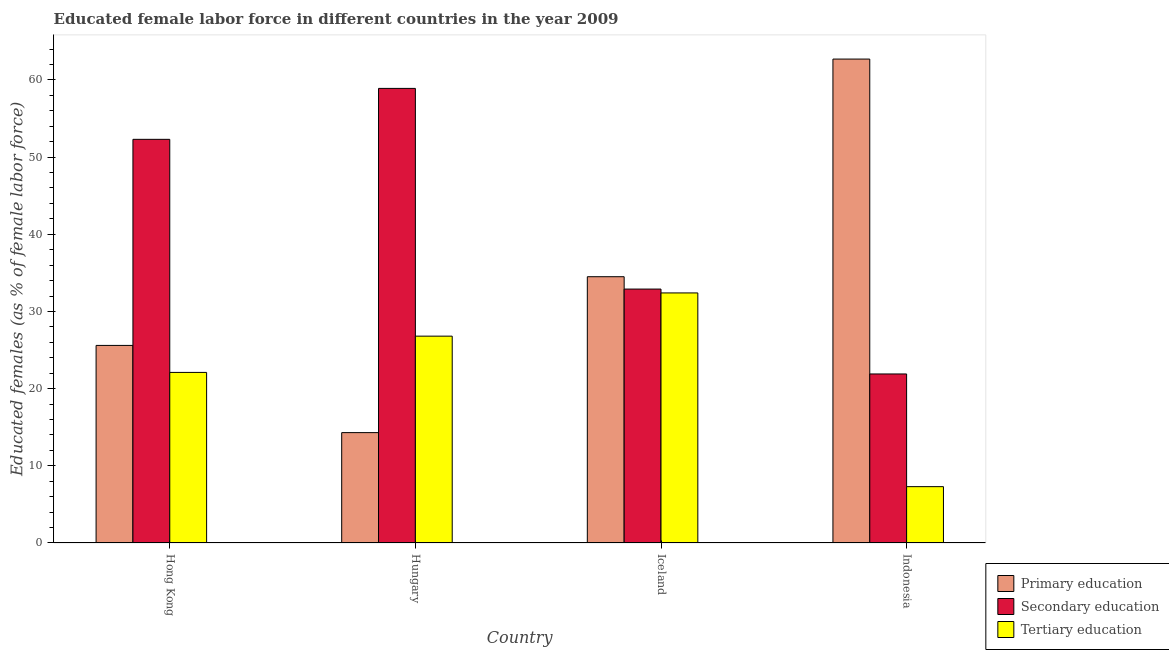How many groups of bars are there?
Offer a terse response. 4. How many bars are there on the 4th tick from the right?
Offer a terse response. 3. What is the label of the 2nd group of bars from the left?
Keep it short and to the point. Hungary. In how many cases, is the number of bars for a given country not equal to the number of legend labels?
Offer a very short reply. 0. What is the percentage of female labor force who received tertiary education in Hong Kong?
Offer a very short reply. 22.1. Across all countries, what is the maximum percentage of female labor force who received secondary education?
Your response must be concise. 58.9. Across all countries, what is the minimum percentage of female labor force who received secondary education?
Your answer should be compact. 21.9. In which country was the percentage of female labor force who received secondary education maximum?
Ensure brevity in your answer.  Hungary. In which country was the percentage of female labor force who received tertiary education minimum?
Provide a short and direct response. Indonesia. What is the total percentage of female labor force who received tertiary education in the graph?
Provide a succinct answer. 88.6. What is the difference between the percentage of female labor force who received secondary education in Iceland and that in Indonesia?
Make the answer very short. 11. What is the difference between the percentage of female labor force who received tertiary education in Indonesia and the percentage of female labor force who received primary education in Hong Kong?
Your answer should be compact. -18.3. What is the average percentage of female labor force who received tertiary education per country?
Your answer should be very brief. 22.15. What is the difference between the percentage of female labor force who received tertiary education and percentage of female labor force who received secondary education in Indonesia?
Keep it short and to the point. -14.6. What is the ratio of the percentage of female labor force who received tertiary education in Hong Kong to that in Hungary?
Provide a succinct answer. 0.82. Is the difference between the percentage of female labor force who received tertiary education in Hungary and Iceland greater than the difference between the percentage of female labor force who received primary education in Hungary and Iceland?
Make the answer very short. Yes. What is the difference between the highest and the second highest percentage of female labor force who received primary education?
Your answer should be very brief. 28.2. What is the difference between the highest and the lowest percentage of female labor force who received primary education?
Your response must be concise. 48.4. In how many countries, is the percentage of female labor force who received primary education greater than the average percentage of female labor force who received primary education taken over all countries?
Provide a short and direct response. 2. What does the 1st bar from the left in Iceland represents?
Your answer should be very brief. Primary education. What does the 2nd bar from the right in Iceland represents?
Keep it short and to the point. Secondary education. Is it the case that in every country, the sum of the percentage of female labor force who received primary education and percentage of female labor force who received secondary education is greater than the percentage of female labor force who received tertiary education?
Offer a very short reply. Yes. How many countries are there in the graph?
Make the answer very short. 4. What is the difference between two consecutive major ticks on the Y-axis?
Offer a terse response. 10. Does the graph contain grids?
Your response must be concise. No. How many legend labels are there?
Offer a very short reply. 3. How are the legend labels stacked?
Your answer should be very brief. Vertical. What is the title of the graph?
Make the answer very short. Educated female labor force in different countries in the year 2009. Does "Interest" appear as one of the legend labels in the graph?
Offer a terse response. No. What is the label or title of the Y-axis?
Offer a terse response. Educated females (as % of female labor force). What is the Educated females (as % of female labor force) of Primary education in Hong Kong?
Provide a succinct answer. 25.6. What is the Educated females (as % of female labor force) of Secondary education in Hong Kong?
Your answer should be compact. 52.3. What is the Educated females (as % of female labor force) of Tertiary education in Hong Kong?
Your answer should be compact. 22.1. What is the Educated females (as % of female labor force) in Primary education in Hungary?
Provide a short and direct response. 14.3. What is the Educated females (as % of female labor force) of Secondary education in Hungary?
Your answer should be very brief. 58.9. What is the Educated females (as % of female labor force) of Tertiary education in Hungary?
Make the answer very short. 26.8. What is the Educated females (as % of female labor force) of Primary education in Iceland?
Your answer should be compact. 34.5. What is the Educated females (as % of female labor force) in Secondary education in Iceland?
Provide a succinct answer. 32.9. What is the Educated females (as % of female labor force) in Tertiary education in Iceland?
Ensure brevity in your answer.  32.4. What is the Educated females (as % of female labor force) of Primary education in Indonesia?
Provide a succinct answer. 62.7. What is the Educated females (as % of female labor force) of Secondary education in Indonesia?
Provide a short and direct response. 21.9. What is the Educated females (as % of female labor force) in Tertiary education in Indonesia?
Your response must be concise. 7.3. Across all countries, what is the maximum Educated females (as % of female labor force) of Primary education?
Provide a succinct answer. 62.7. Across all countries, what is the maximum Educated females (as % of female labor force) of Secondary education?
Provide a succinct answer. 58.9. Across all countries, what is the maximum Educated females (as % of female labor force) of Tertiary education?
Offer a very short reply. 32.4. Across all countries, what is the minimum Educated females (as % of female labor force) in Primary education?
Your answer should be compact. 14.3. Across all countries, what is the minimum Educated females (as % of female labor force) in Secondary education?
Your answer should be compact. 21.9. Across all countries, what is the minimum Educated females (as % of female labor force) of Tertiary education?
Keep it short and to the point. 7.3. What is the total Educated females (as % of female labor force) in Primary education in the graph?
Provide a short and direct response. 137.1. What is the total Educated females (as % of female labor force) in Secondary education in the graph?
Keep it short and to the point. 166. What is the total Educated females (as % of female labor force) of Tertiary education in the graph?
Offer a terse response. 88.6. What is the difference between the Educated females (as % of female labor force) in Primary education in Hong Kong and that in Hungary?
Offer a terse response. 11.3. What is the difference between the Educated females (as % of female labor force) of Primary education in Hong Kong and that in Iceland?
Provide a succinct answer. -8.9. What is the difference between the Educated females (as % of female labor force) of Primary education in Hong Kong and that in Indonesia?
Provide a succinct answer. -37.1. What is the difference between the Educated females (as % of female labor force) of Secondary education in Hong Kong and that in Indonesia?
Your answer should be compact. 30.4. What is the difference between the Educated females (as % of female labor force) in Primary education in Hungary and that in Iceland?
Provide a succinct answer. -20.2. What is the difference between the Educated females (as % of female labor force) in Tertiary education in Hungary and that in Iceland?
Provide a short and direct response. -5.6. What is the difference between the Educated females (as % of female labor force) of Primary education in Hungary and that in Indonesia?
Provide a short and direct response. -48.4. What is the difference between the Educated females (as % of female labor force) of Tertiary education in Hungary and that in Indonesia?
Your response must be concise. 19.5. What is the difference between the Educated females (as % of female labor force) of Primary education in Iceland and that in Indonesia?
Give a very brief answer. -28.2. What is the difference between the Educated females (as % of female labor force) of Secondary education in Iceland and that in Indonesia?
Make the answer very short. 11. What is the difference between the Educated females (as % of female labor force) of Tertiary education in Iceland and that in Indonesia?
Make the answer very short. 25.1. What is the difference between the Educated females (as % of female labor force) in Primary education in Hong Kong and the Educated females (as % of female labor force) in Secondary education in Hungary?
Provide a short and direct response. -33.3. What is the difference between the Educated females (as % of female labor force) of Primary education in Hong Kong and the Educated females (as % of female labor force) of Tertiary education in Hungary?
Keep it short and to the point. -1.2. What is the difference between the Educated females (as % of female labor force) in Primary education in Hong Kong and the Educated females (as % of female labor force) in Tertiary education in Iceland?
Give a very brief answer. -6.8. What is the difference between the Educated females (as % of female labor force) in Secondary education in Hong Kong and the Educated females (as % of female labor force) in Tertiary education in Iceland?
Offer a very short reply. 19.9. What is the difference between the Educated females (as % of female labor force) of Primary education in Hong Kong and the Educated females (as % of female labor force) of Tertiary education in Indonesia?
Offer a terse response. 18.3. What is the difference between the Educated females (as % of female labor force) of Primary education in Hungary and the Educated females (as % of female labor force) of Secondary education in Iceland?
Offer a terse response. -18.6. What is the difference between the Educated females (as % of female labor force) of Primary education in Hungary and the Educated females (as % of female labor force) of Tertiary education in Iceland?
Your answer should be compact. -18.1. What is the difference between the Educated females (as % of female labor force) of Primary education in Hungary and the Educated females (as % of female labor force) of Secondary education in Indonesia?
Ensure brevity in your answer.  -7.6. What is the difference between the Educated females (as % of female labor force) in Secondary education in Hungary and the Educated females (as % of female labor force) in Tertiary education in Indonesia?
Your answer should be very brief. 51.6. What is the difference between the Educated females (as % of female labor force) in Primary education in Iceland and the Educated females (as % of female labor force) in Tertiary education in Indonesia?
Offer a very short reply. 27.2. What is the difference between the Educated females (as % of female labor force) of Secondary education in Iceland and the Educated females (as % of female labor force) of Tertiary education in Indonesia?
Offer a terse response. 25.6. What is the average Educated females (as % of female labor force) of Primary education per country?
Ensure brevity in your answer.  34.27. What is the average Educated females (as % of female labor force) in Secondary education per country?
Ensure brevity in your answer.  41.5. What is the average Educated females (as % of female labor force) of Tertiary education per country?
Offer a terse response. 22.15. What is the difference between the Educated females (as % of female labor force) of Primary education and Educated females (as % of female labor force) of Secondary education in Hong Kong?
Provide a short and direct response. -26.7. What is the difference between the Educated females (as % of female labor force) of Primary education and Educated females (as % of female labor force) of Tertiary education in Hong Kong?
Make the answer very short. 3.5. What is the difference between the Educated females (as % of female labor force) of Secondary education and Educated females (as % of female labor force) of Tertiary education in Hong Kong?
Your answer should be compact. 30.2. What is the difference between the Educated females (as % of female labor force) in Primary education and Educated females (as % of female labor force) in Secondary education in Hungary?
Offer a terse response. -44.6. What is the difference between the Educated females (as % of female labor force) in Primary education and Educated females (as % of female labor force) in Tertiary education in Hungary?
Provide a short and direct response. -12.5. What is the difference between the Educated females (as % of female labor force) of Secondary education and Educated females (as % of female labor force) of Tertiary education in Hungary?
Keep it short and to the point. 32.1. What is the difference between the Educated females (as % of female labor force) in Secondary education and Educated females (as % of female labor force) in Tertiary education in Iceland?
Your response must be concise. 0.5. What is the difference between the Educated females (as % of female labor force) in Primary education and Educated females (as % of female labor force) in Secondary education in Indonesia?
Your answer should be compact. 40.8. What is the difference between the Educated females (as % of female labor force) of Primary education and Educated females (as % of female labor force) of Tertiary education in Indonesia?
Offer a very short reply. 55.4. What is the difference between the Educated females (as % of female labor force) of Secondary education and Educated females (as % of female labor force) of Tertiary education in Indonesia?
Ensure brevity in your answer.  14.6. What is the ratio of the Educated females (as % of female labor force) of Primary education in Hong Kong to that in Hungary?
Your answer should be compact. 1.79. What is the ratio of the Educated females (as % of female labor force) of Secondary education in Hong Kong to that in Hungary?
Provide a succinct answer. 0.89. What is the ratio of the Educated females (as % of female labor force) of Tertiary education in Hong Kong to that in Hungary?
Keep it short and to the point. 0.82. What is the ratio of the Educated females (as % of female labor force) of Primary education in Hong Kong to that in Iceland?
Give a very brief answer. 0.74. What is the ratio of the Educated females (as % of female labor force) in Secondary education in Hong Kong to that in Iceland?
Provide a short and direct response. 1.59. What is the ratio of the Educated females (as % of female labor force) of Tertiary education in Hong Kong to that in Iceland?
Your answer should be very brief. 0.68. What is the ratio of the Educated females (as % of female labor force) of Primary education in Hong Kong to that in Indonesia?
Ensure brevity in your answer.  0.41. What is the ratio of the Educated females (as % of female labor force) of Secondary education in Hong Kong to that in Indonesia?
Offer a terse response. 2.39. What is the ratio of the Educated females (as % of female labor force) of Tertiary education in Hong Kong to that in Indonesia?
Offer a terse response. 3.03. What is the ratio of the Educated females (as % of female labor force) of Primary education in Hungary to that in Iceland?
Your response must be concise. 0.41. What is the ratio of the Educated females (as % of female labor force) of Secondary education in Hungary to that in Iceland?
Your response must be concise. 1.79. What is the ratio of the Educated females (as % of female labor force) in Tertiary education in Hungary to that in Iceland?
Offer a very short reply. 0.83. What is the ratio of the Educated females (as % of female labor force) in Primary education in Hungary to that in Indonesia?
Offer a very short reply. 0.23. What is the ratio of the Educated females (as % of female labor force) of Secondary education in Hungary to that in Indonesia?
Provide a succinct answer. 2.69. What is the ratio of the Educated females (as % of female labor force) in Tertiary education in Hungary to that in Indonesia?
Provide a succinct answer. 3.67. What is the ratio of the Educated females (as % of female labor force) in Primary education in Iceland to that in Indonesia?
Keep it short and to the point. 0.55. What is the ratio of the Educated females (as % of female labor force) in Secondary education in Iceland to that in Indonesia?
Your answer should be very brief. 1.5. What is the ratio of the Educated females (as % of female labor force) of Tertiary education in Iceland to that in Indonesia?
Your answer should be very brief. 4.44. What is the difference between the highest and the second highest Educated females (as % of female labor force) of Primary education?
Your answer should be very brief. 28.2. What is the difference between the highest and the second highest Educated females (as % of female labor force) in Tertiary education?
Your answer should be compact. 5.6. What is the difference between the highest and the lowest Educated females (as % of female labor force) of Primary education?
Ensure brevity in your answer.  48.4. What is the difference between the highest and the lowest Educated females (as % of female labor force) in Tertiary education?
Ensure brevity in your answer.  25.1. 